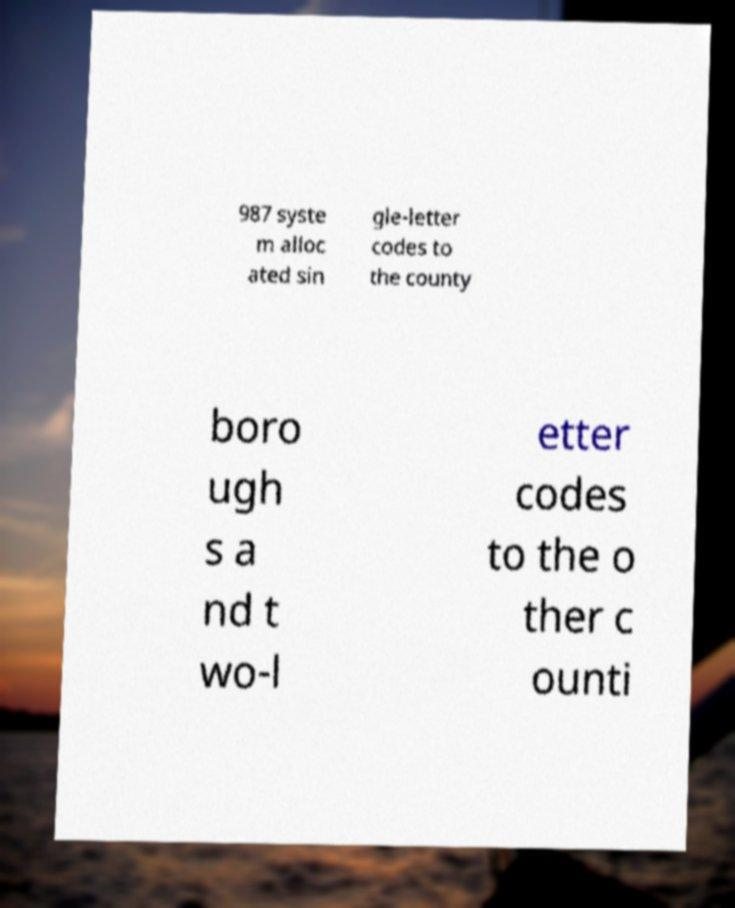Please identify and transcribe the text found in this image. 987 syste m alloc ated sin gle-letter codes to the county boro ugh s a nd t wo-l etter codes to the o ther c ounti 